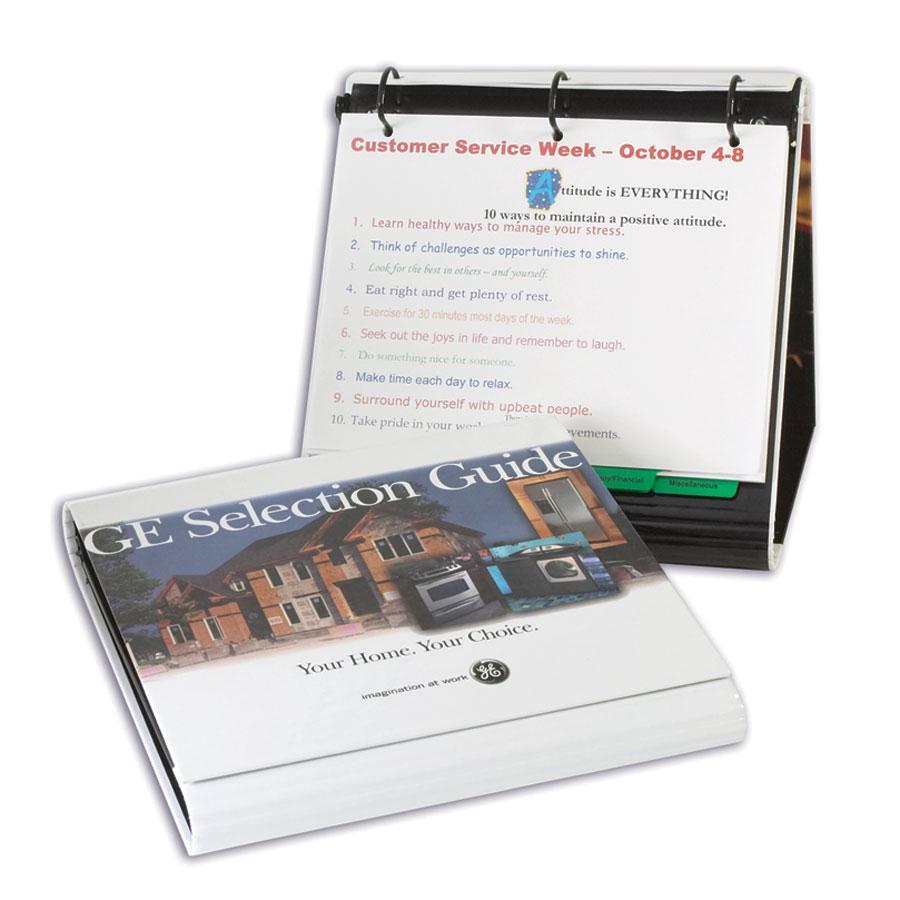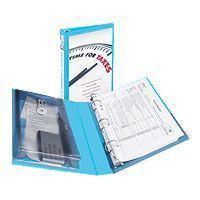The first image is the image on the left, the second image is the image on the right. Examine the images to the left and right. Is the description "One of the binders has an interior pocket containing a calculator." accurate? Answer yes or no. Yes. The first image is the image on the left, the second image is the image on the right. For the images displayed, is the sentence "One of the binders itself, not the pages within, has maps as a design, on the visible part of the binder." factually correct? Answer yes or no. No. 